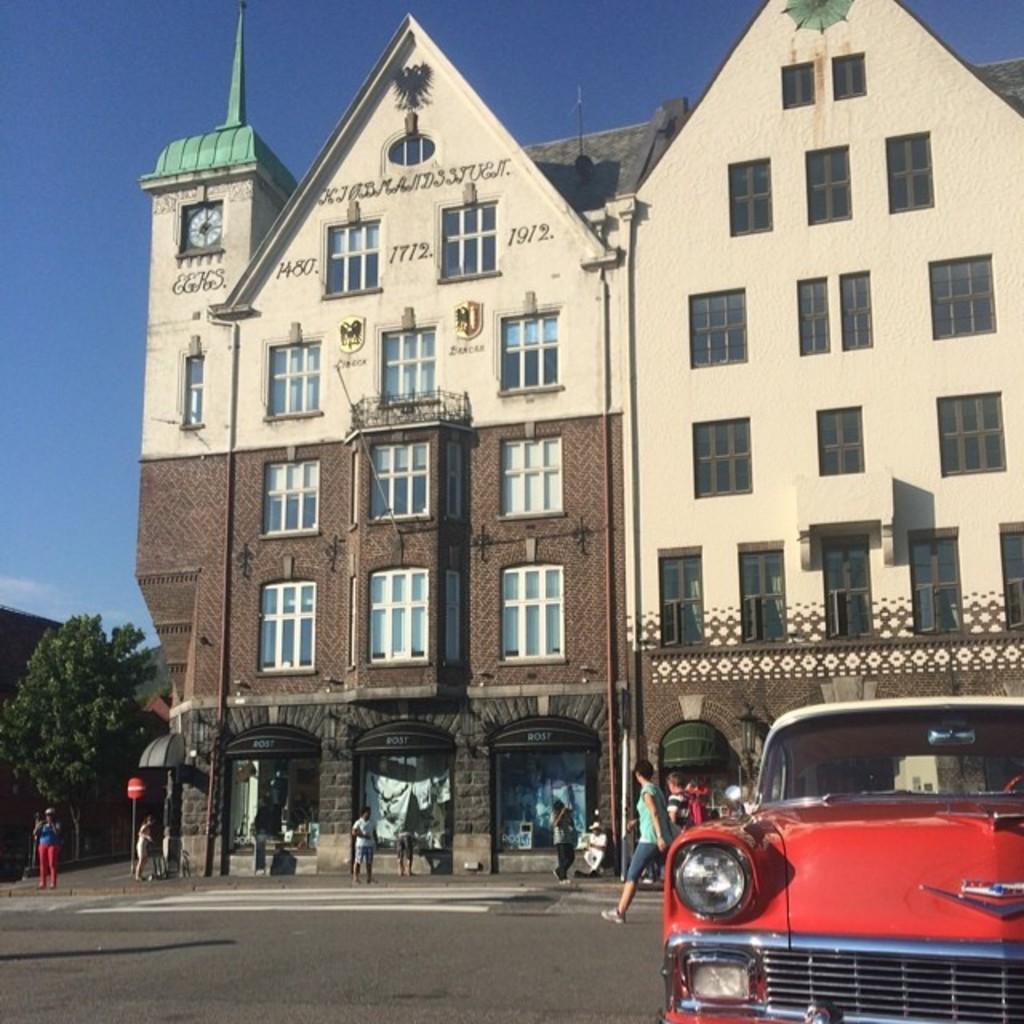Please provide a concise description of this image. In this picture we can see a vehicle, people on the road, here we can see buildings, trees and some objects and we can see sky in the background. 